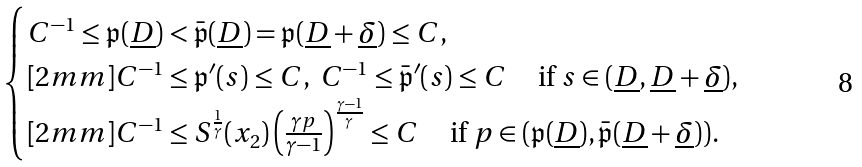<formula> <loc_0><loc_0><loc_500><loc_500>\begin{cases} C ^ { - 1 } \leq \mathfrak { p } ( \underline { D } ) < \bar { \mathfrak { p } } ( \underline { D } ) = \mathfrak { p } ( \underline { D } + \underline { \delta } ) \leq C , \\ [ 2 m m ] C ^ { - 1 } \leq \mathfrak { p } ^ { \prime } ( s ) \leq C , \ C ^ { - 1 } \leq \bar { \mathfrak { p } } ^ { \prime } ( s ) \leq C \quad \, \text {if} \ s \in ( \underline { D } , \underline { D } + \underline { \delta } ) , \\ [ 2 m m ] C ^ { - 1 } \leq S ^ { \frac { 1 } { \gamma } } ( x _ { 2 } ) \left ( \frac { \gamma p } { \gamma - 1 } \right ) ^ { \frac { \gamma - 1 } { \gamma } } \leq C \quad \, \text {if} \ p \in ( \mathfrak { p } ( \underline { D } ) , \bar { \mathfrak { p } } ( \underline { D } + \underline { \delta } ) ) . \end{cases}</formula> 